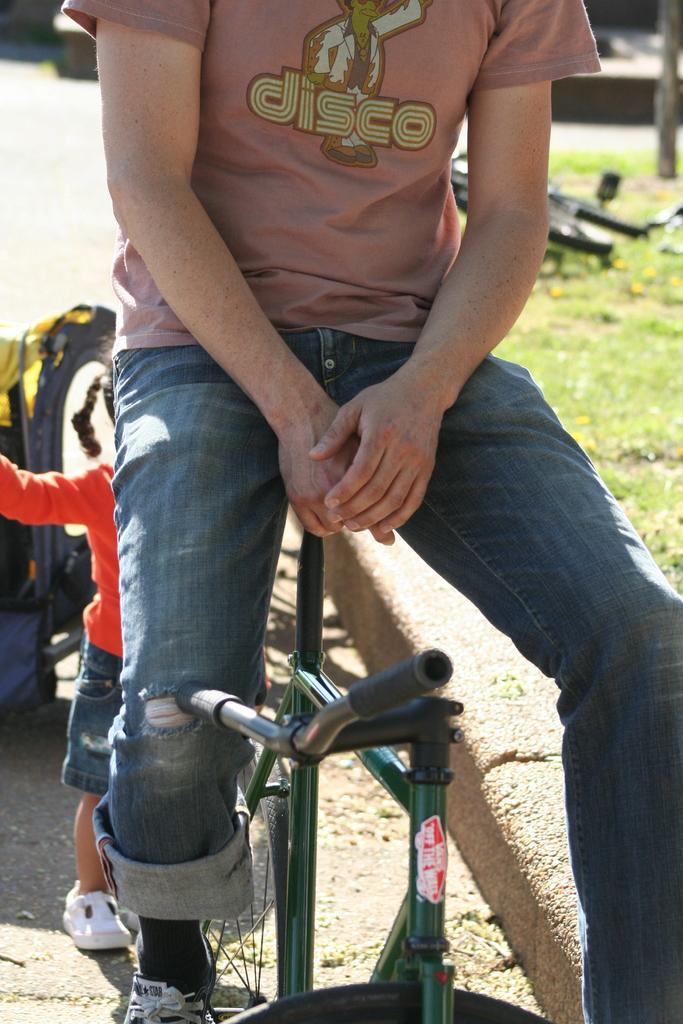Please provide a concise description of this image. This person is sitting on a bicycle. Far there is a bicycle on grass. Backside of this person there is a kid. 